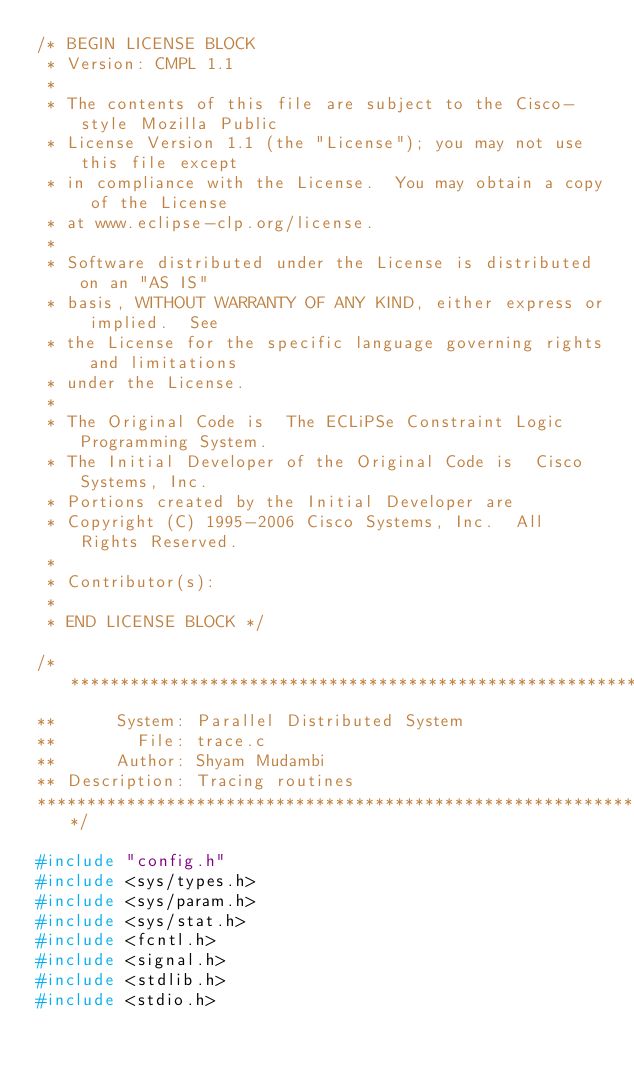Convert code to text. <code><loc_0><loc_0><loc_500><loc_500><_C_>/* BEGIN LICENSE BLOCK
 * Version: CMPL 1.1
 *
 * The contents of this file are subject to the Cisco-style Mozilla Public
 * License Version 1.1 (the "License"); you may not use this file except
 * in compliance with the License.  You may obtain a copy of the License
 * at www.eclipse-clp.org/license.
 * 
 * Software distributed under the License is distributed on an "AS IS"
 * basis, WITHOUT WARRANTY OF ANY KIND, either express or implied.  See
 * the License for the specific language governing rights and limitations
 * under the License. 
 * 
 * The Original Code is  The ECLiPSe Constraint Logic Programming System. 
 * The Initial Developer of the Original Code is  Cisco Systems, Inc. 
 * Portions created by the Initial Developer are
 * Copyright (C) 1995-2006 Cisco Systems, Inc.  All Rights Reserved.
 * 
 * Contributor(s): 
 * 
 * END LICENSE BLOCK */

/**********************************************************************
**      System: Parallel Distributed System
**        File: trace.c
**      Author: Shyam Mudambi
** Description: Tracing routines
***********************************************************************/

#include "config.h"
#include <sys/types.h>
#include <sys/param.h>
#include <sys/stat.h>
#include <fcntl.h>
#include <signal.h>
#include <stdlib.h>
#include <stdio.h></code> 